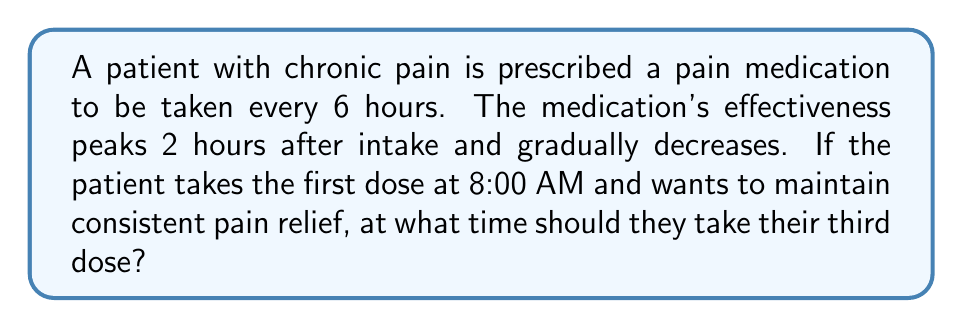What is the answer to this math problem? Let's approach this step-by-step:

1) First, let's establish a timeline:
   - 1st dose: 8:00 AM
   - 2nd dose: 6 hours later

2) Calculate the time of the 2nd dose:
   $8:00 \text{ AM} + 6 \text{ hours} = 2:00 \text{ PM}$

3) The question asks for the time of the 3rd dose, which will be 6 hours after the 2nd dose:
   $2:00 \text{ PM} + 6 \text{ hours} = 8:00 \text{ PM}$

4) To verify, let's check the interval between the 1st and 3rd doses:
   $8:00 \text{ PM} - 8:00 \text{ AM} = 12 \text{ hours}$
   
   This confirms that the 3rd dose is indeed 12 hours (or two 6-hour intervals) after the 1st dose.

5) Therefore, to maintain consistent pain relief, the patient should take their third dose at 8:00 PM.
Answer: 8:00 PM 